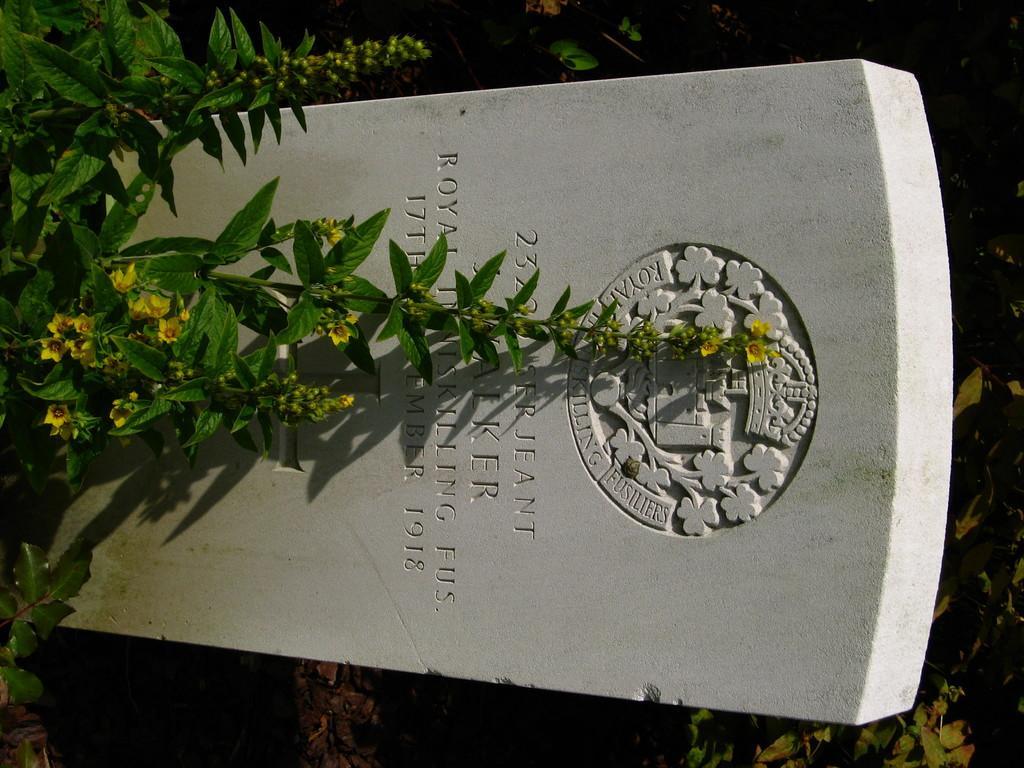Can you describe this image briefly? In this image I can see the cemetery, few flowers in yellow color and the plants in green color. 